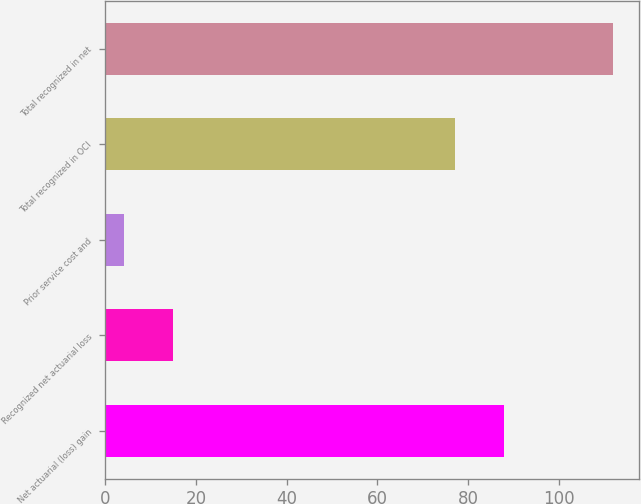<chart> <loc_0><loc_0><loc_500><loc_500><bar_chart><fcel>Net actuarial (loss) gain<fcel>Recognized net actuarial loss<fcel>Prior service cost and<fcel>Total recognized in OCI<fcel>Total recognized in net<nl><fcel>88<fcel>14.8<fcel>4<fcel>77<fcel>112<nl></chart> 